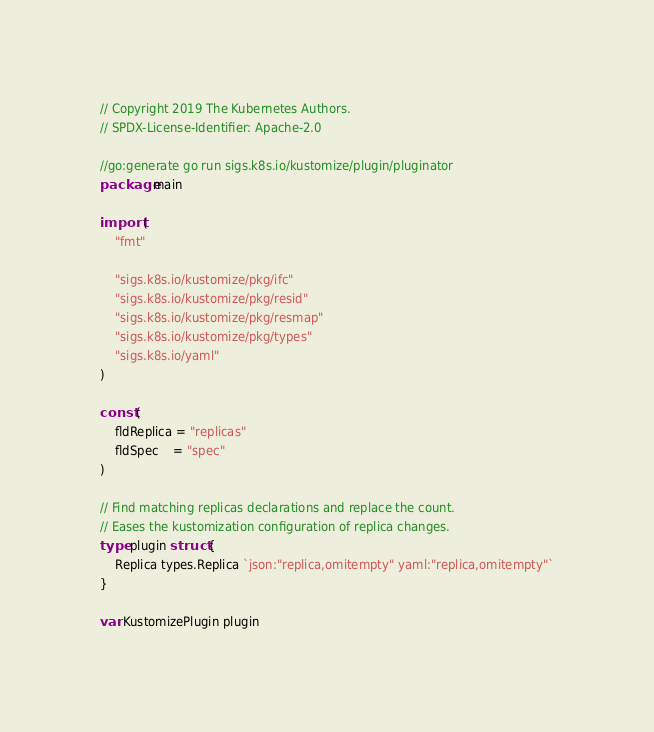Convert code to text. <code><loc_0><loc_0><loc_500><loc_500><_Go_>// Copyright 2019 The Kubernetes Authors.
// SPDX-License-Identifier: Apache-2.0

//go:generate go run sigs.k8s.io/kustomize/plugin/pluginator
package main

import (
	"fmt"

	"sigs.k8s.io/kustomize/pkg/ifc"
	"sigs.k8s.io/kustomize/pkg/resid"
	"sigs.k8s.io/kustomize/pkg/resmap"
	"sigs.k8s.io/kustomize/pkg/types"
	"sigs.k8s.io/yaml"
)

const (
	fldReplica = "replicas"
	fldSpec    = "spec"
)

// Find matching replicas declarations and replace the count.
// Eases the kustomization configuration of replica changes.
type plugin struct {
	Replica types.Replica `json:"replica,omitempty" yaml:"replica,omitempty"`
}

var KustomizePlugin plugin
</code> 